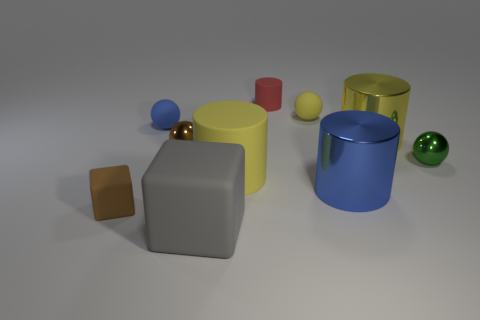Subtract 1 spheres. How many spheres are left? 3 Subtract all spheres. How many objects are left? 6 Subtract all green rubber blocks. Subtract all small shiny spheres. How many objects are left? 8 Add 4 small green metallic objects. How many small green metallic objects are left? 5 Add 1 small blue things. How many small blue things exist? 2 Subtract 0 green cubes. How many objects are left? 10 